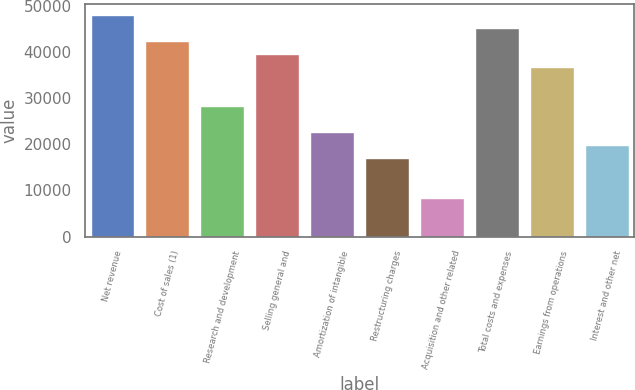Convert chart to OTSL. <chart><loc_0><loc_0><loc_500><loc_500><bar_chart><fcel>Net revenue<fcel>Cost of sales (1)<fcel>Research and development<fcel>Selling general and<fcel>Amortization of intangible<fcel>Restructuring charges<fcel>Acquisition and other related<fcel>Total costs and expenses<fcel>Earnings from operations<fcel>Interest and other net<nl><fcel>47861.8<fcel>42231<fcel>28154<fcel>39415.6<fcel>22523.2<fcel>16892.5<fcel>8446.32<fcel>45046.4<fcel>36600.2<fcel>19707.9<nl></chart> 